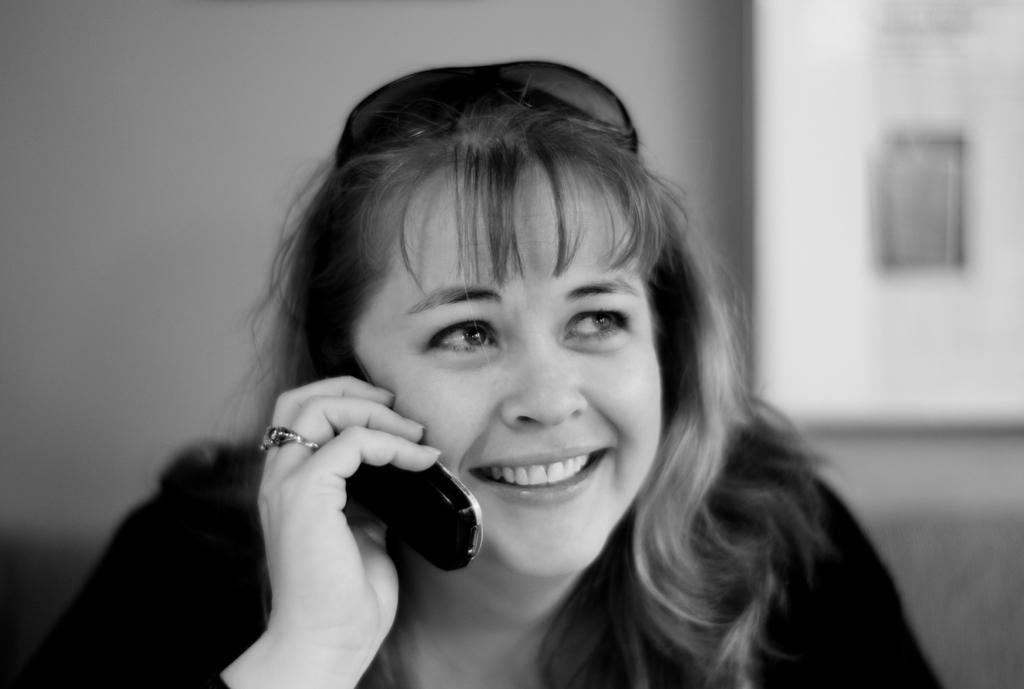Who is the main subject in the image? There is a woman in the image. What is the woman holding in the image? The woman is holding a cellphone. What additional accessory is the woman wearing in the image? The woman has goggles on her head. Can you describe the background of the image? The background of the image is blurry. What type of ball is being juggled by the cow in the image? There is no cow or ball present in the image; it features a woman holding a cellphone and wearing goggles. 